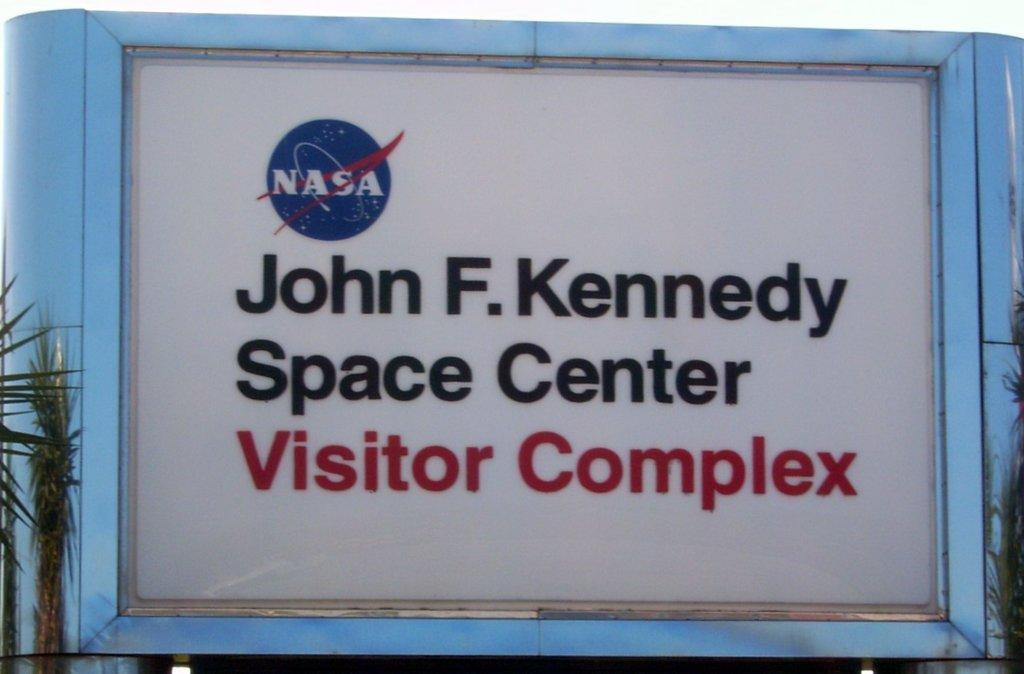<image>
Summarize the visual content of the image. Sign mentions from Nasa that it is the John F. Kennedy Space Center Visitor Complex. 